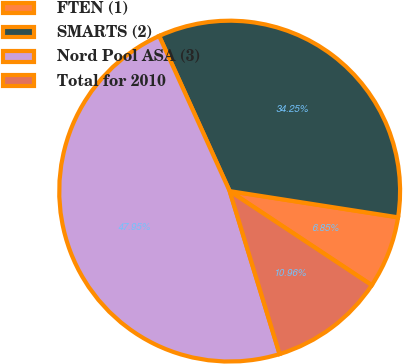Convert chart to OTSL. <chart><loc_0><loc_0><loc_500><loc_500><pie_chart><fcel>FTEN (1)<fcel>SMARTS (2)<fcel>Nord Pool ASA (3)<fcel>Total for 2010<nl><fcel>6.85%<fcel>34.25%<fcel>47.95%<fcel>10.96%<nl></chart> 